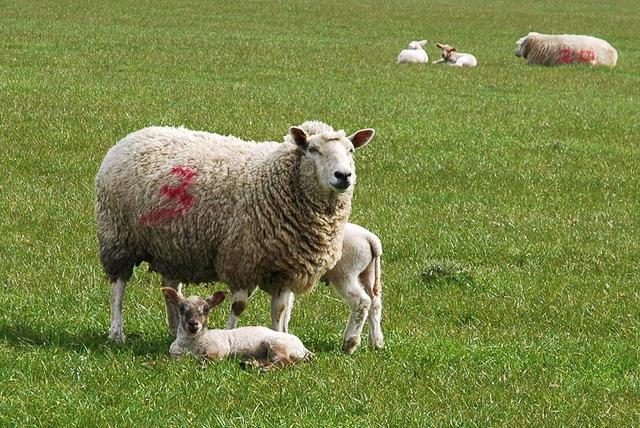Is this animal in an enclosure?
Be succinct. No. Is this sheep bleeding?
Answer briefly. No. Who sprayed the sheep?
Keep it brief. Farmer. What number is written on the sheet?
Answer briefly. 3. How many sheep are babies?
Quick response, please. 4. Is there any road in the picture?
Answer briefly. No. How many baby sheep are in the picture?
Quick response, please. 4. Are the animals standing close or far apart from each other?
Quick response, please. Close. Are these the same type of animal?
Answer briefly. Yes. How many sheep are in the picture?
Be succinct. 6. 